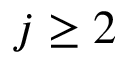<formula> <loc_0><loc_0><loc_500><loc_500>j \geq 2</formula> 